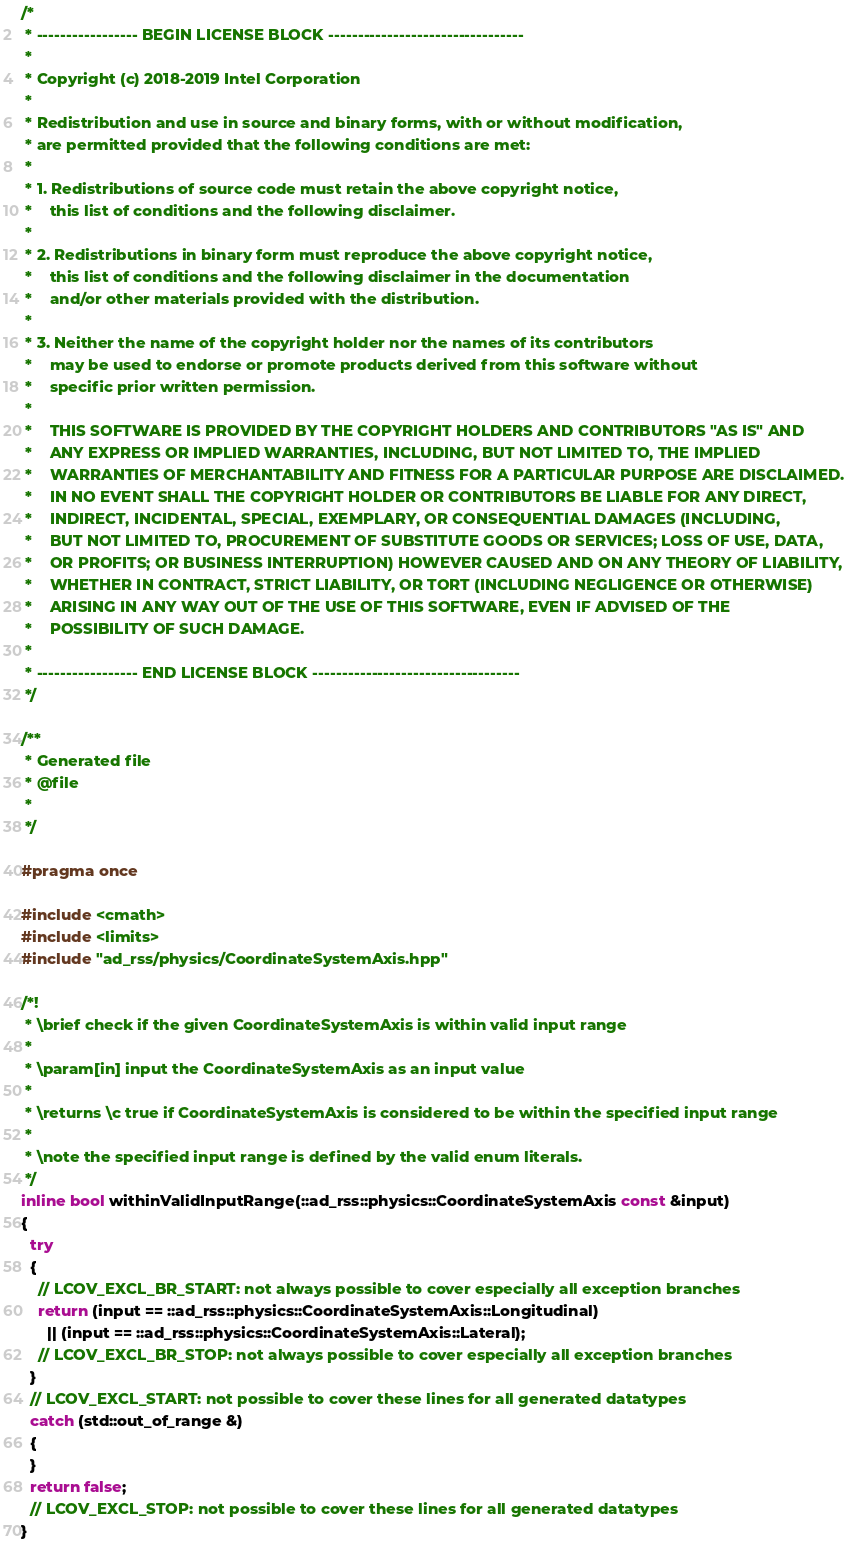<code> <loc_0><loc_0><loc_500><loc_500><_C++_>/*
 * ----------------- BEGIN LICENSE BLOCK ---------------------------------
 *
 * Copyright (c) 2018-2019 Intel Corporation
 *
 * Redistribution and use in source and binary forms, with or without modification,
 * are permitted provided that the following conditions are met:
 *
 * 1. Redistributions of source code must retain the above copyright notice,
 *    this list of conditions and the following disclaimer.
 *
 * 2. Redistributions in binary form must reproduce the above copyright notice,
 *    this list of conditions and the following disclaimer in the documentation
 *    and/or other materials provided with the distribution.
 *
 * 3. Neither the name of the copyright holder nor the names of its contributors
 *    may be used to endorse or promote products derived from this software without
 *    specific prior written permission.
 *
 *    THIS SOFTWARE IS PROVIDED BY THE COPYRIGHT HOLDERS AND CONTRIBUTORS "AS IS" AND
 *    ANY EXPRESS OR IMPLIED WARRANTIES, INCLUDING, BUT NOT LIMITED TO, THE IMPLIED
 *    WARRANTIES OF MERCHANTABILITY AND FITNESS FOR A PARTICULAR PURPOSE ARE DISCLAIMED.
 *    IN NO EVENT SHALL THE COPYRIGHT HOLDER OR CONTRIBUTORS BE LIABLE FOR ANY DIRECT,
 *    INDIRECT, INCIDENTAL, SPECIAL, EXEMPLARY, OR CONSEQUENTIAL DAMAGES (INCLUDING,
 *    BUT NOT LIMITED TO, PROCUREMENT OF SUBSTITUTE GOODS OR SERVICES; LOSS OF USE, DATA,
 *    OR PROFITS; OR BUSINESS INTERRUPTION) HOWEVER CAUSED AND ON ANY THEORY OF LIABILITY,
 *    WHETHER IN CONTRACT, STRICT LIABILITY, OR TORT (INCLUDING NEGLIGENCE OR OTHERWISE)
 *    ARISING IN ANY WAY OUT OF THE USE OF THIS SOFTWARE, EVEN IF ADVISED OF THE
 *    POSSIBILITY OF SUCH DAMAGE.
 *
 * ----------------- END LICENSE BLOCK -----------------------------------
 */

/**
 * Generated file
 * @file
 *
 */

#pragma once

#include <cmath>
#include <limits>
#include "ad_rss/physics/CoordinateSystemAxis.hpp"

/*!
 * \brief check if the given CoordinateSystemAxis is within valid input range
 *
 * \param[in] input the CoordinateSystemAxis as an input value
 *
 * \returns \c true if CoordinateSystemAxis is considered to be within the specified input range
 *
 * \note the specified input range is defined by the valid enum literals.
 */
inline bool withinValidInputRange(::ad_rss::physics::CoordinateSystemAxis const &input)
{
  try
  {
    // LCOV_EXCL_BR_START: not always possible to cover especially all exception branches
    return (input == ::ad_rss::physics::CoordinateSystemAxis::Longitudinal)
      || (input == ::ad_rss::physics::CoordinateSystemAxis::Lateral);
    // LCOV_EXCL_BR_STOP: not always possible to cover especially all exception branches
  }
  // LCOV_EXCL_START: not possible to cover these lines for all generated datatypes
  catch (std::out_of_range &)
  {
  }
  return false;
  // LCOV_EXCL_STOP: not possible to cover these lines for all generated datatypes
}
</code> 